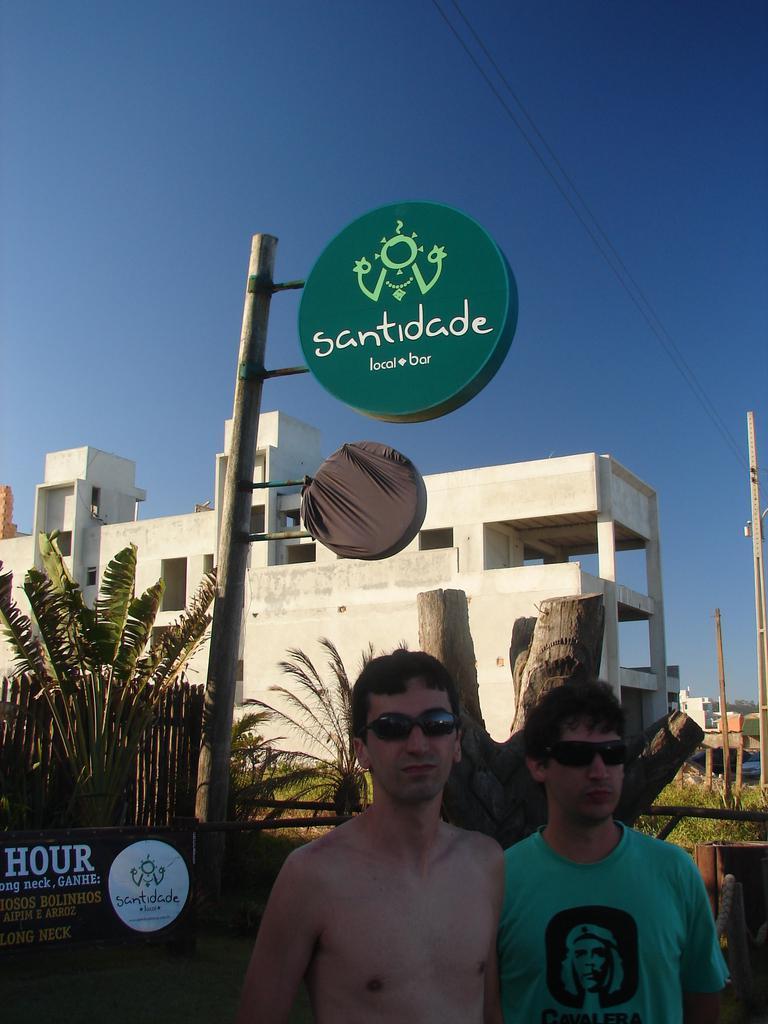Describe this image in one or two sentences. In this picture we can see the building. At the bottom there is a man who is wearing goggle, beside him we can see another man who is wearing t-shirt and goggles. Both of them were standing on the road. At the back we can see the poles and tree wood. On the right we can see the electric poles and wires are connected to it. On the background we can see trees, plants and grass. At the top there is a sky. 